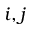<formula> <loc_0><loc_0><loc_500><loc_500>i , j</formula> 